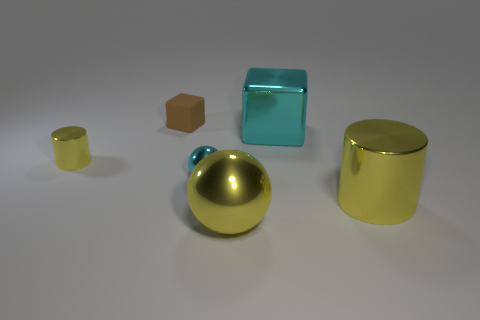What number of things are tiny cyan rubber cylinders or blocks on the left side of the large yellow shiny sphere?
Offer a very short reply. 1. What number of cubes are right of the yellow metallic thing that is in front of the big yellow metal object that is behind the large sphere?
Your answer should be very brief. 1. What is the material of the thing that is the same color as the metallic cube?
Offer a very short reply. Metal. What number of large gray blocks are there?
Provide a short and direct response. 0. Does the yellow metallic cylinder on the left side of the brown matte thing have the same size as the big yellow ball?
Your response must be concise. No. What number of metallic things are either tiny cyan balls or red blocks?
Offer a very short reply. 1. There is a sphere behind the large cylinder; how many yellow metal objects are in front of it?
Give a very brief answer. 2. What is the shape of the large metal object that is on the left side of the large shiny cylinder and in front of the big cyan block?
Your answer should be compact. Sphere. There is a cyan thing that is right of the yellow sphere in front of the cylinder that is on the right side of the small block; what is it made of?
Keep it short and to the point. Metal. The block that is the same color as the small sphere is what size?
Provide a succinct answer. Large. 